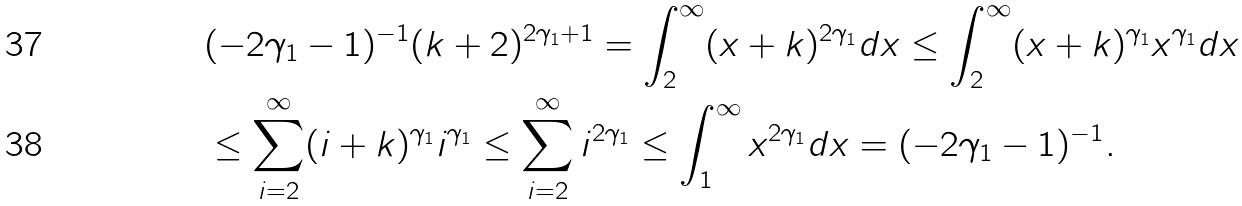Convert formula to latex. <formula><loc_0><loc_0><loc_500><loc_500>& ( - 2 \gamma _ { 1 } - 1 ) ^ { - 1 } ( k + 2 ) ^ { 2 \gamma _ { 1 } + 1 } = \int _ { 2 } ^ { \infty } ( x + k ) ^ { 2 \gamma _ { 1 } } d x \leq \int _ { 2 } ^ { \infty } ( x + k ) ^ { \gamma _ { 1 } } x ^ { \gamma _ { 1 } } d x \\ & \leq \sum _ { i = 2 } ^ { \infty } ( i + k ) ^ { \gamma _ { 1 } } i ^ { \gamma _ { 1 } } \leq \sum _ { i = 2 } ^ { \infty } i ^ { 2 \gamma _ { 1 } } \leq \int _ { 1 } ^ { \infty } x ^ { 2 \gamma _ { 1 } } d x = ( - 2 \gamma _ { 1 } - 1 ) ^ { - 1 } .</formula> 